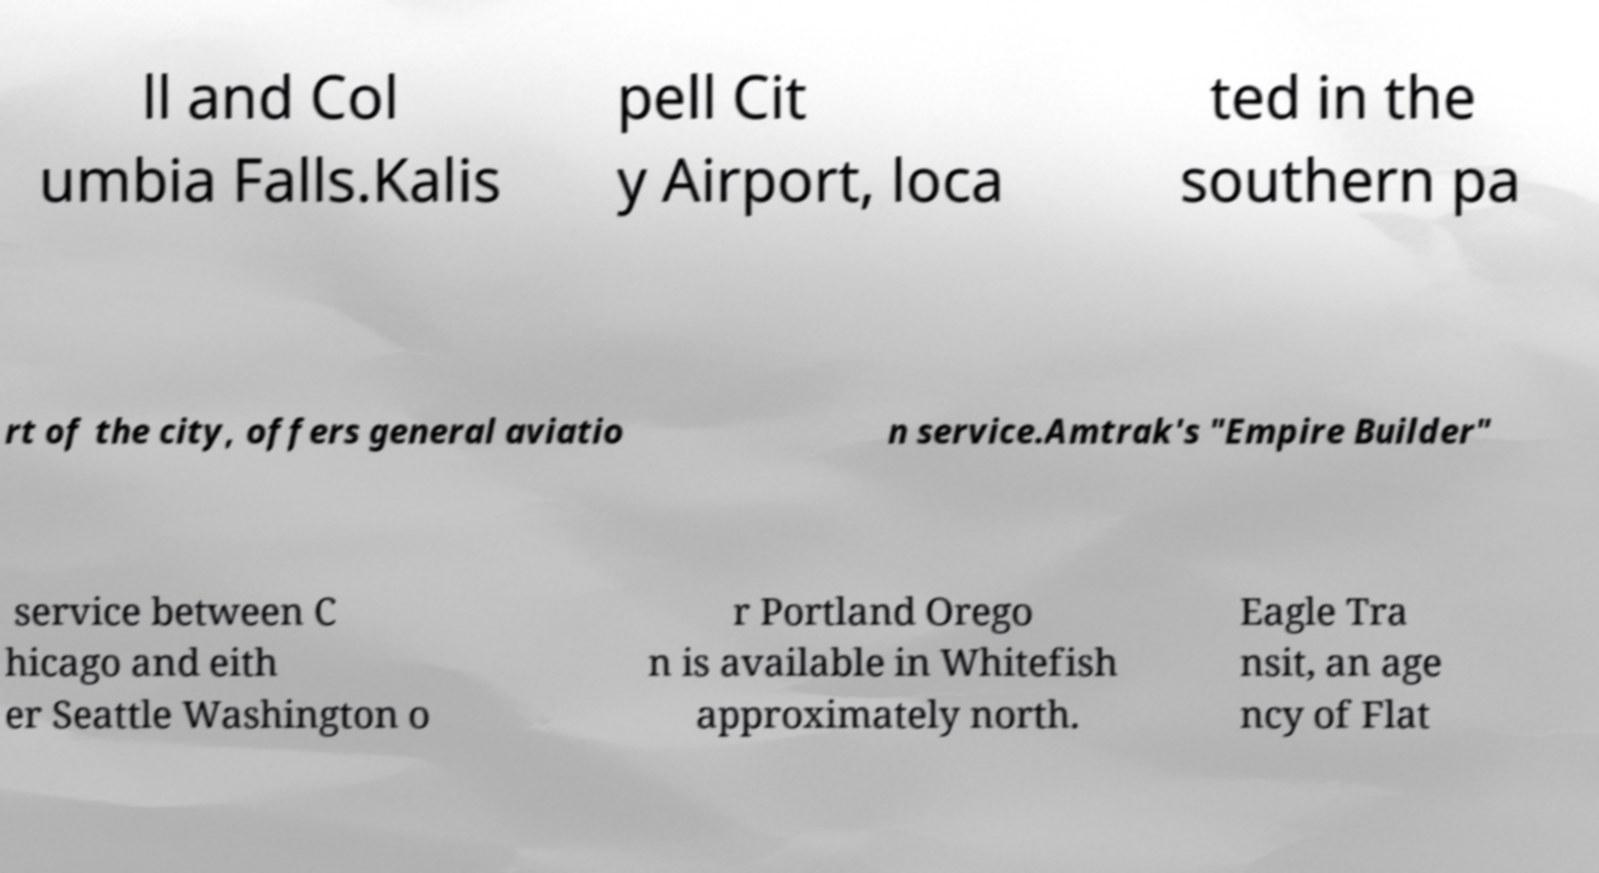Please identify and transcribe the text found in this image. ll and Col umbia Falls.Kalis pell Cit y Airport, loca ted in the southern pa rt of the city, offers general aviatio n service.Amtrak's "Empire Builder" service between C hicago and eith er Seattle Washington o r Portland Orego n is available in Whitefish approximately north. Eagle Tra nsit, an age ncy of Flat 